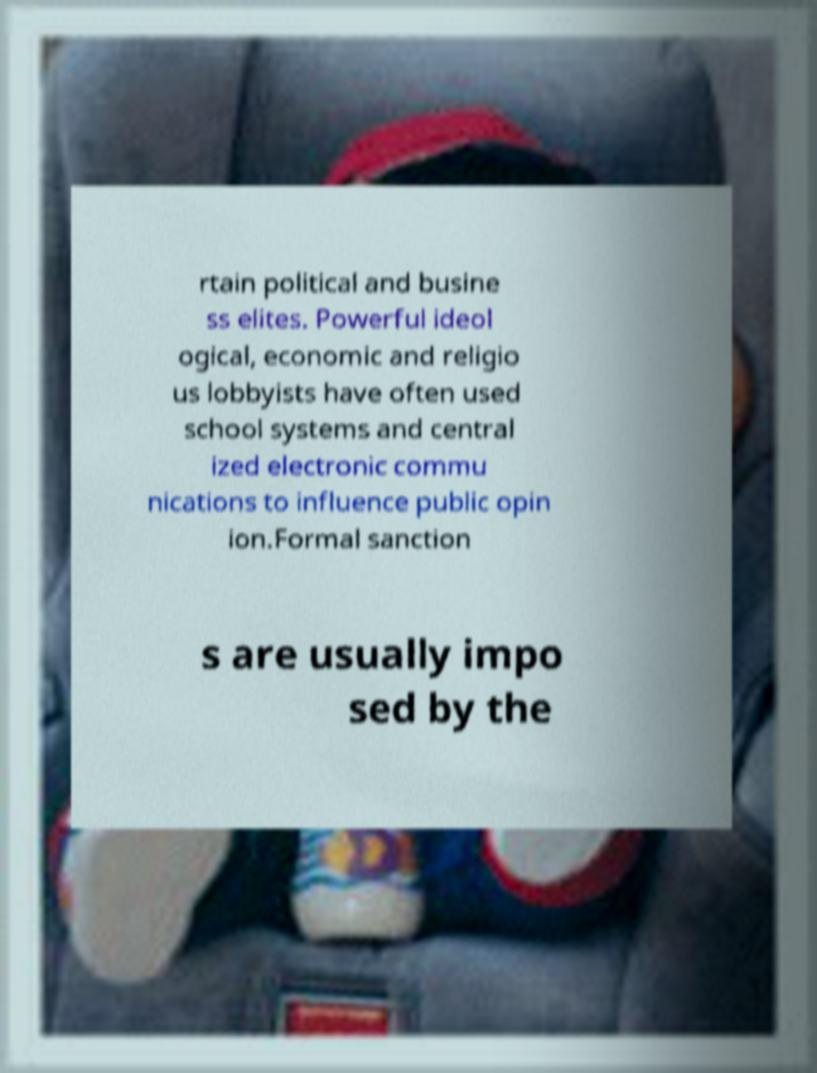For documentation purposes, I need the text within this image transcribed. Could you provide that? rtain political and busine ss elites. Powerful ideol ogical, economic and religio us lobbyists have often used school systems and central ized electronic commu nications to influence public opin ion.Formal sanction s are usually impo sed by the 